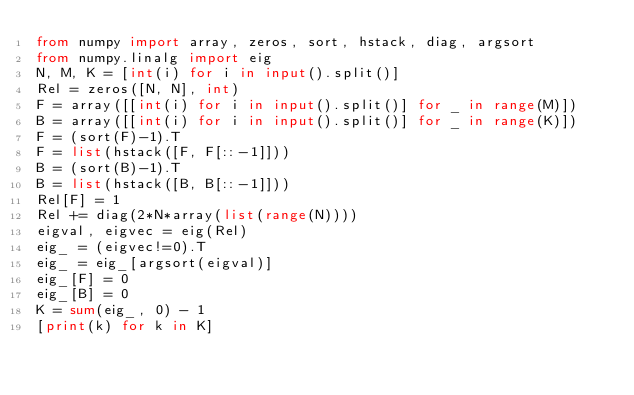Convert code to text. <code><loc_0><loc_0><loc_500><loc_500><_Python_>from numpy import array, zeros, sort, hstack, diag, argsort
from numpy.linalg import eig
N, M, K = [int(i) for i in input().split()]
Rel = zeros([N, N], int)
F = array([[int(i) for i in input().split()] for _ in range(M)])
B = array([[int(i) for i in input().split()] for _ in range(K)])
F = (sort(F)-1).T
F = list(hstack([F, F[::-1]]))
B = (sort(B)-1).T
B = list(hstack([B, B[::-1]]))
Rel[F] = 1
Rel += diag(2*N*array(list(range(N))))
eigval, eigvec = eig(Rel)
eig_ = (eigvec!=0).T
eig_ = eig_[argsort(eigval)]
eig_[F] = 0
eig_[B] = 0
K = sum(eig_, 0) - 1
[print(k) for k in K]</code> 